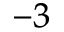<formula> <loc_0><loc_0><loc_500><loc_500>^ { - 3 }</formula> 